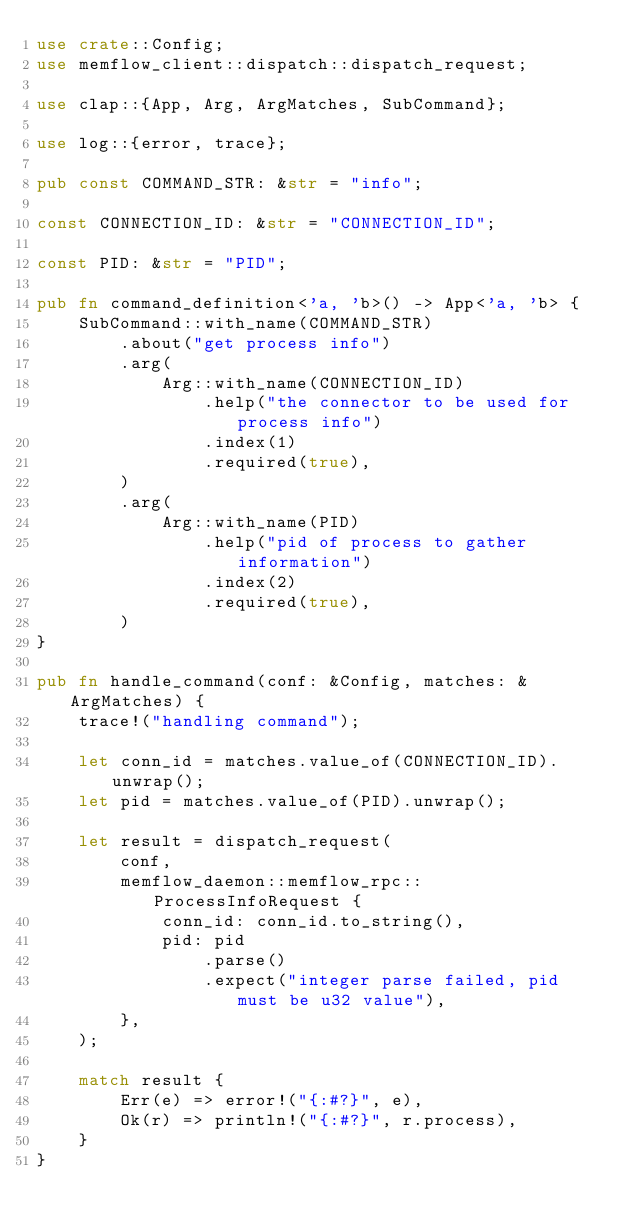Convert code to text. <code><loc_0><loc_0><loc_500><loc_500><_Rust_>use crate::Config;
use memflow_client::dispatch::dispatch_request;

use clap::{App, Arg, ArgMatches, SubCommand};

use log::{error, trace};

pub const COMMAND_STR: &str = "info";

const CONNECTION_ID: &str = "CONNECTION_ID";

const PID: &str = "PID";

pub fn command_definition<'a, 'b>() -> App<'a, 'b> {
    SubCommand::with_name(COMMAND_STR)
        .about("get process info")
        .arg(
            Arg::with_name(CONNECTION_ID)
                .help("the connector to be used for process info")
                .index(1)
                .required(true),
        )
        .arg(
            Arg::with_name(PID)
                .help("pid of process to gather information")
                .index(2)
                .required(true),
        )
}

pub fn handle_command(conf: &Config, matches: &ArgMatches) {
    trace!("handling command");

    let conn_id = matches.value_of(CONNECTION_ID).unwrap();
    let pid = matches.value_of(PID).unwrap();

    let result = dispatch_request(
        conf,
        memflow_daemon::memflow_rpc::ProcessInfoRequest {
            conn_id: conn_id.to_string(),
            pid: pid
                .parse()
                .expect("integer parse failed, pid must be u32 value"),
        },
    );

    match result {
        Err(e) => error!("{:#?}", e),
        Ok(r) => println!("{:#?}", r.process),
    }
}
</code> 